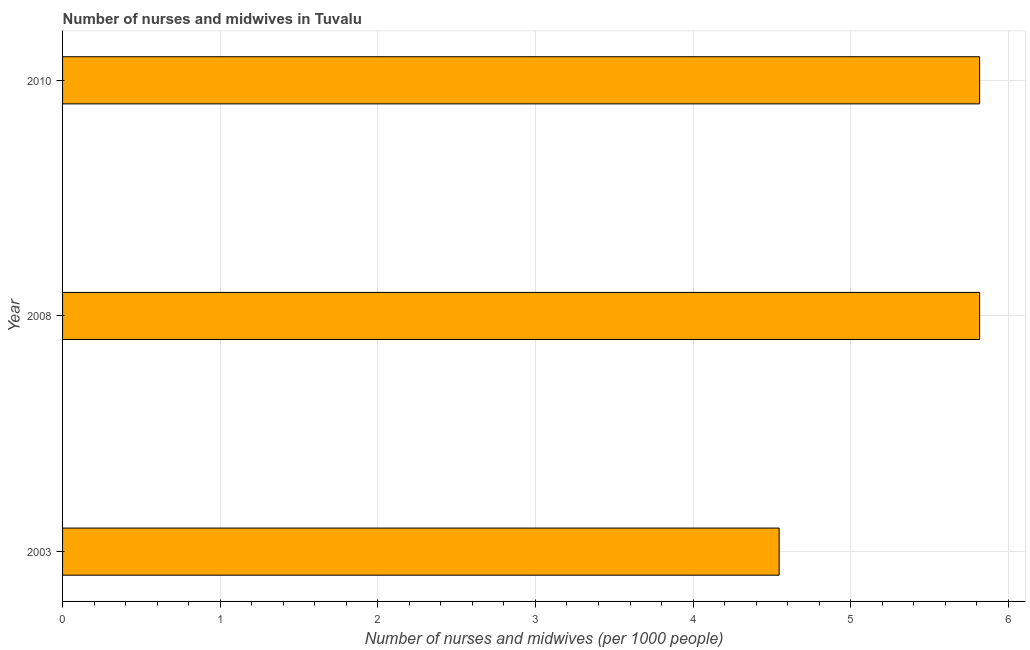What is the title of the graph?
Make the answer very short. Number of nurses and midwives in Tuvalu. What is the label or title of the X-axis?
Keep it short and to the point. Number of nurses and midwives (per 1000 people). What is the label or title of the Y-axis?
Give a very brief answer. Year. What is the number of nurses and midwives in 2010?
Offer a terse response. 5.82. Across all years, what is the maximum number of nurses and midwives?
Provide a succinct answer. 5.82. Across all years, what is the minimum number of nurses and midwives?
Keep it short and to the point. 4.55. In which year was the number of nurses and midwives maximum?
Make the answer very short. 2008. In which year was the number of nurses and midwives minimum?
Provide a succinct answer. 2003. What is the sum of the number of nurses and midwives?
Your answer should be compact. 16.18. What is the difference between the number of nurses and midwives in 2003 and 2010?
Give a very brief answer. -1.27. What is the average number of nurses and midwives per year?
Offer a very short reply. 5.39. What is the median number of nurses and midwives?
Your response must be concise. 5.82. Do a majority of the years between 2008 and 2010 (inclusive) have number of nurses and midwives greater than 2.2 ?
Offer a terse response. Yes. What is the ratio of the number of nurses and midwives in 2003 to that in 2010?
Offer a very short reply. 0.78. Is the difference between the number of nurses and midwives in 2008 and 2010 greater than the difference between any two years?
Keep it short and to the point. No. What is the difference between the highest and the lowest number of nurses and midwives?
Provide a short and direct response. 1.27. How many bars are there?
Offer a very short reply. 3. What is the difference between two consecutive major ticks on the X-axis?
Offer a very short reply. 1. Are the values on the major ticks of X-axis written in scientific E-notation?
Your answer should be compact. No. What is the Number of nurses and midwives (per 1000 people) in 2003?
Ensure brevity in your answer.  4.55. What is the Number of nurses and midwives (per 1000 people) in 2008?
Make the answer very short. 5.82. What is the Number of nurses and midwives (per 1000 people) in 2010?
Keep it short and to the point. 5.82. What is the difference between the Number of nurses and midwives (per 1000 people) in 2003 and 2008?
Offer a terse response. -1.27. What is the difference between the Number of nurses and midwives (per 1000 people) in 2003 and 2010?
Offer a very short reply. -1.27. What is the ratio of the Number of nurses and midwives (per 1000 people) in 2003 to that in 2008?
Provide a succinct answer. 0.78. What is the ratio of the Number of nurses and midwives (per 1000 people) in 2003 to that in 2010?
Offer a terse response. 0.78. What is the ratio of the Number of nurses and midwives (per 1000 people) in 2008 to that in 2010?
Offer a very short reply. 1. 